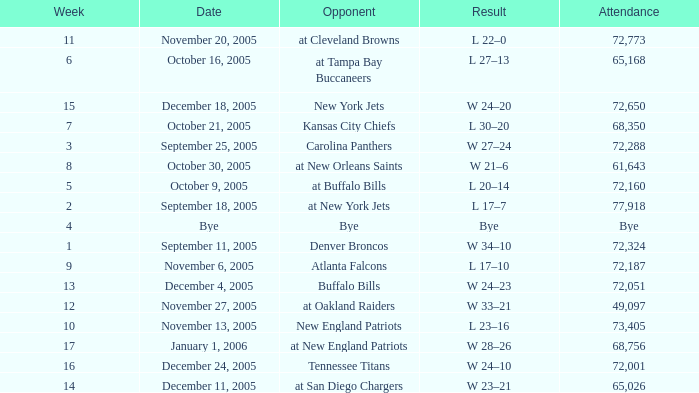What is the Date of the game with an attendance of 72,051 after Week 9? December 4, 2005. 